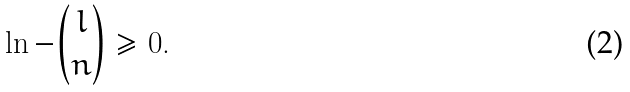<formula> <loc_0><loc_0><loc_500><loc_500>\ln - { l \choose n } \geq 0 .</formula> 